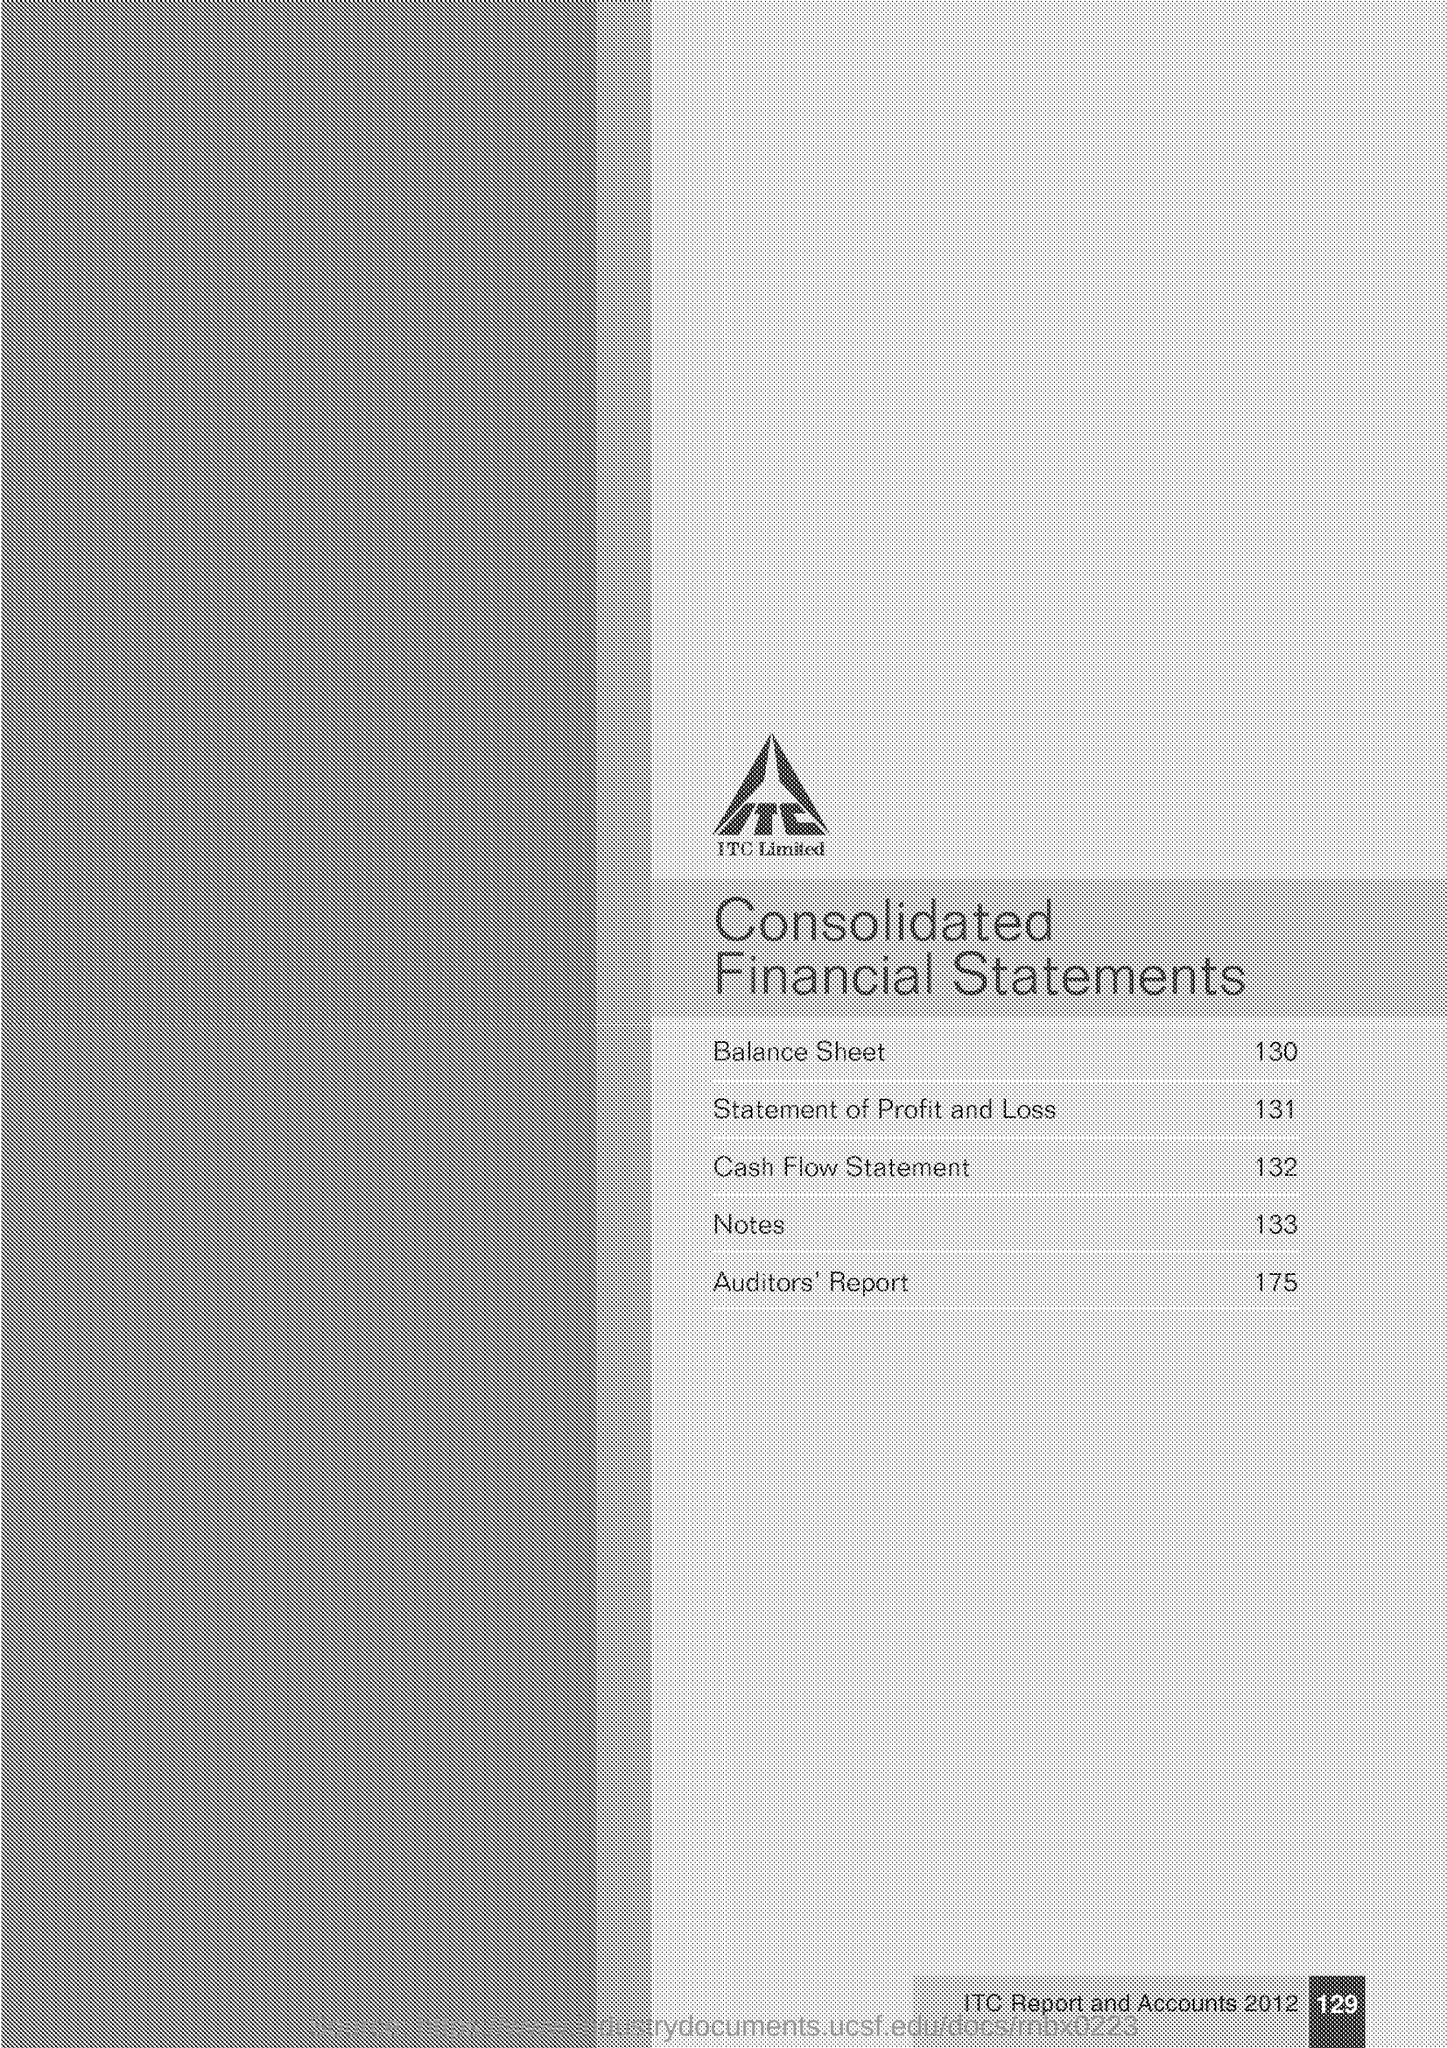Indicate a few pertinent items in this graphic. The page number of the document is 129. The page number for the section titled 'Profit and Loss' is 131. The page number of the Auditors Report is 175. Please provide the page number of the 'Notes' section. The page number of "Balance Sheet" is 130. 